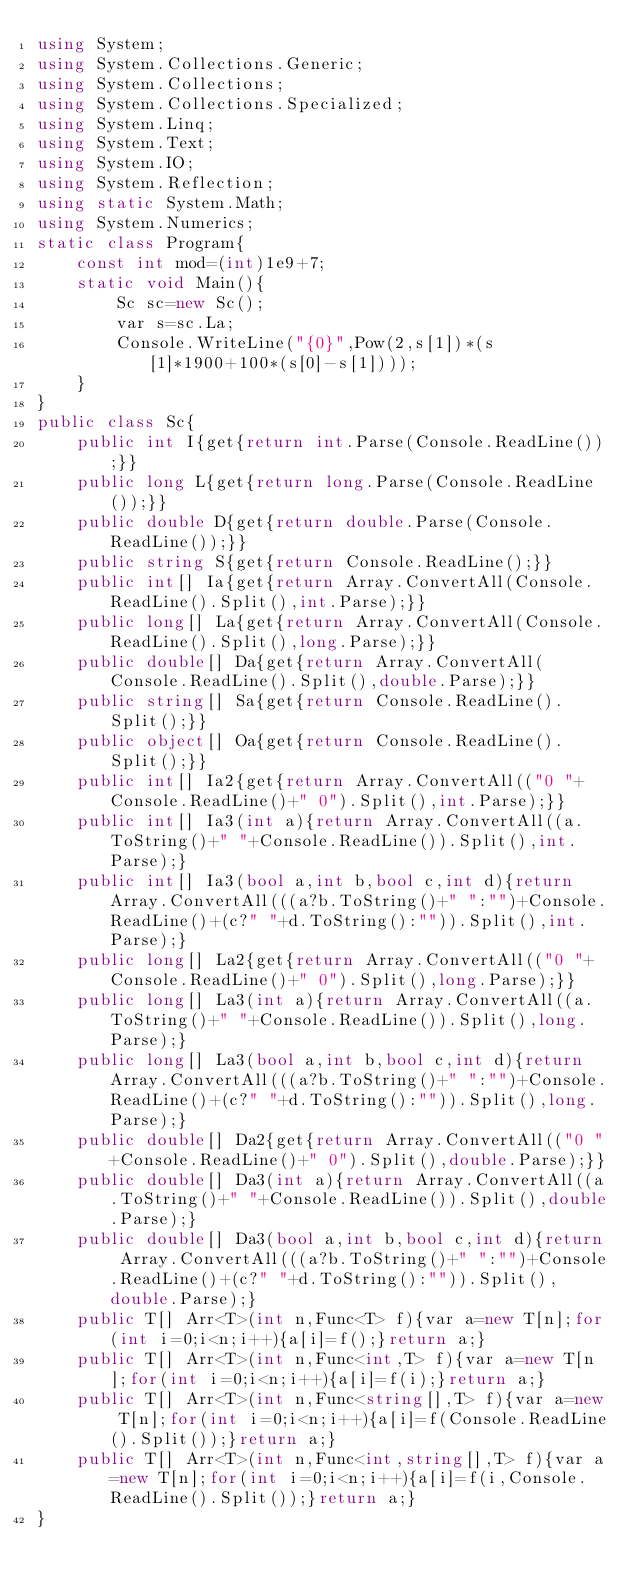<code> <loc_0><loc_0><loc_500><loc_500><_C#_>using System;
using System.Collections.Generic;
using System.Collections;
using System.Collections.Specialized;
using System.Linq;
using System.Text;
using System.IO;
using System.Reflection;
using static System.Math;
using System.Numerics;
static class Program{
	const int mod=(int)1e9+7;
	static void Main(){
		Sc sc=new Sc();
		var s=sc.La;
		Console.WriteLine("{0}",Pow(2,s[1])*(s[1]*1900+100*(s[0]-s[1])));
	}
}
public class Sc{
	public int I{get{return int.Parse(Console.ReadLine());}}
	public long L{get{return long.Parse(Console.ReadLine());}}
	public double D{get{return double.Parse(Console.ReadLine());}}
	public string S{get{return Console.ReadLine();}}
	public int[] Ia{get{return Array.ConvertAll(Console.ReadLine().Split(),int.Parse);}}
	public long[] La{get{return Array.ConvertAll(Console.ReadLine().Split(),long.Parse);}}
	public double[] Da{get{return Array.ConvertAll(Console.ReadLine().Split(),double.Parse);}}
	public string[] Sa{get{return Console.ReadLine().Split();}}
	public object[] Oa{get{return Console.ReadLine().Split();}}
	public int[] Ia2{get{return Array.ConvertAll(("0 "+Console.ReadLine()+" 0").Split(),int.Parse);}}
	public int[] Ia3(int a){return Array.ConvertAll((a.ToString()+" "+Console.ReadLine()).Split(),int.Parse);}
	public int[] Ia3(bool a,int b,bool c,int d){return Array.ConvertAll(((a?b.ToString()+" ":"")+Console.ReadLine()+(c?" "+d.ToString():"")).Split(),int.Parse);}
	public long[] La2{get{return Array.ConvertAll(("0 "+Console.ReadLine()+" 0").Split(),long.Parse);}}
	public long[] La3(int a){return Array.ConvertAll((a.ToString()+" "+Console.ReadLine()).Split(),long.Parse);}
	public long[] La3(bool a,int b,bool c,int d){return Array.ConvertAll(((a?b.ToString()+" ":"")+Console.ReadLine()+(c?" "+d.ToString():"")).Split(),long.Parse);}
	public double[] Da2{get{return Array.ConvertAll(("0 "+Console.ReadLine()+" 0").Split(),double.Parse);}}
	public double[] Da3(int a){return Array.ConvertAll((a.ToString()+" "+Console.ReadLine()).Split(),double.Parse);}
	public double[] Da3(bool a,int b,bool c,int d){return Array.ConvertAll(((a?b.ToString()+" ":"")+Console.ReadLine()+(c?" "+d.ToString():"")).Split(),double.Parse);}
	public T[] Arr<T>(int n,Func<T> f){var a=new T[n];for(int i=0;i<n;i++){a[i]=f();}return a;}
	public T[] Arr<T>(int n,Func<int,T> f){var a=new T[n];for(int i=0;i<n;i++){a[i]=f(i);}return a;}
	public T[] Arr<T>(int n,Func<string[],T> f){var a=new T[n];for(int i=0;i<n;i++){a[i]=f(Console.ReadLine().Split());}return a;}
	public T[] Arr<T>(int n,Func<int,string[],T> f){var a=new T[n];for(int i=0;i<n;i++){a[i]=f(i,Console.ReadLine().Split());}return a;}
}</code> 